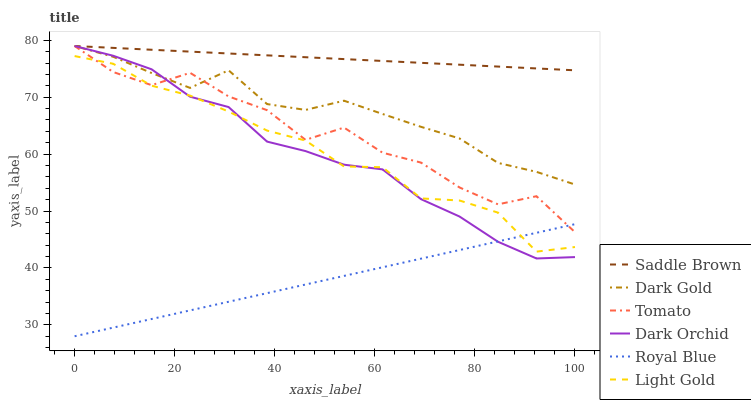Does Dark Gold have the minimum area under the curve?
Answer yes or no. No. Does Dark Gold have the maximum area under the curve?
Answer yes or no. No. Is Dark Gold the smoothest?
Answer yes or no. No. Is Dark Gold the roughest?
Answer yes or no. No. Does Dark Gold have the lowest value?
Answer yes or no. No. Does Royal Blue have the highest value?
Answer yes or no. No. Is Royal Blue less than Saddle Brown?
Answer yes or no. Yes. Is Dark Gold greater than Light Gold?
Answer yes or no. Yes. Does Royal Blue intersect Saddle Brown?
Answer yes or no. No. 